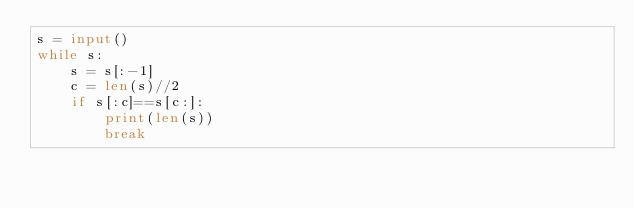<code> <loc_0><loc_0><loc_500><loc_500><_Python_>s = input()
while s:
    s = s[:-1]
    c = len(s)//2
    if s[:c]==s[c:]:
        print(len(s))
        break</code> 